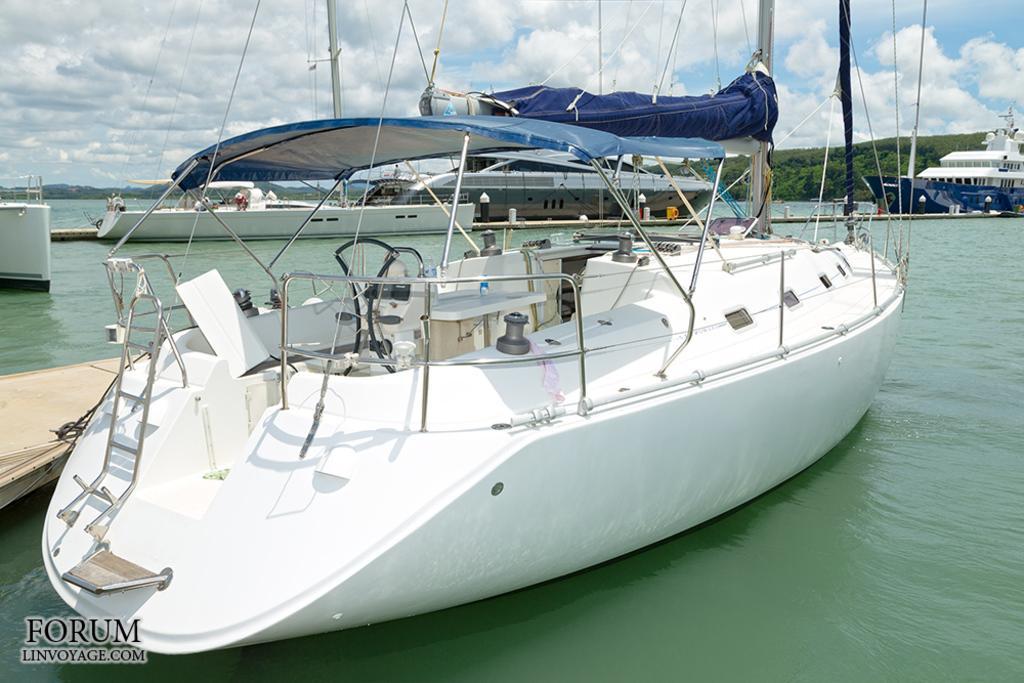Can you describe this image briefly? There is a white color boat parked at the shipyard. Which is on the water. In the background, there are other boats on the water, there are mountains and there are clouds in the blue sky. 